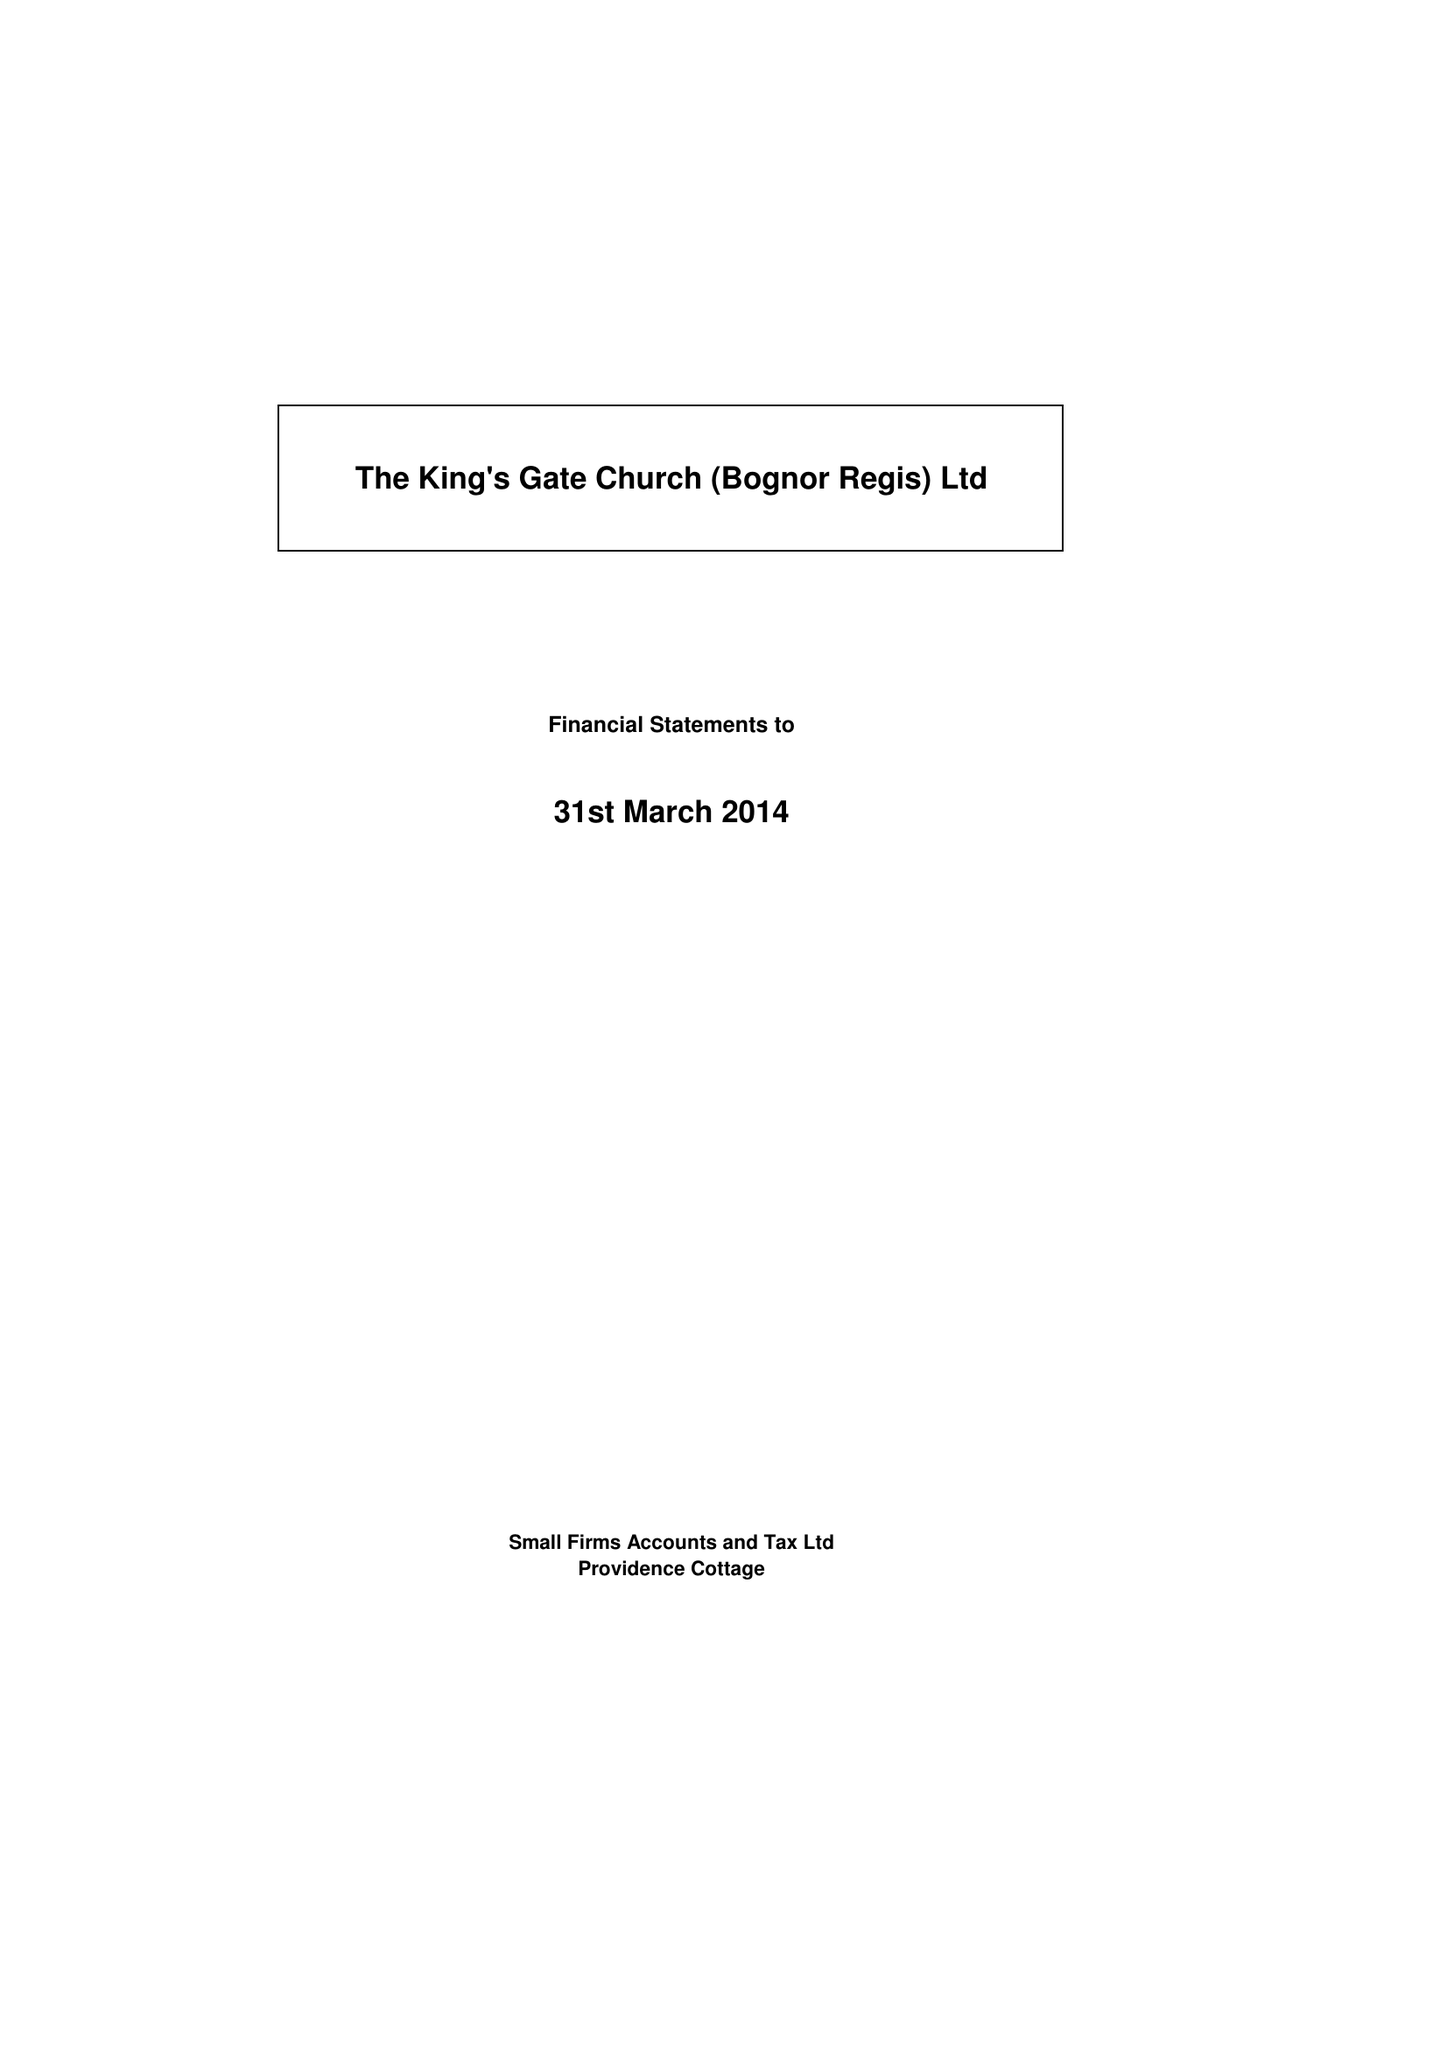What is the value for the report_date?
Answer the question using a single word or phrase. 2014-03-31 